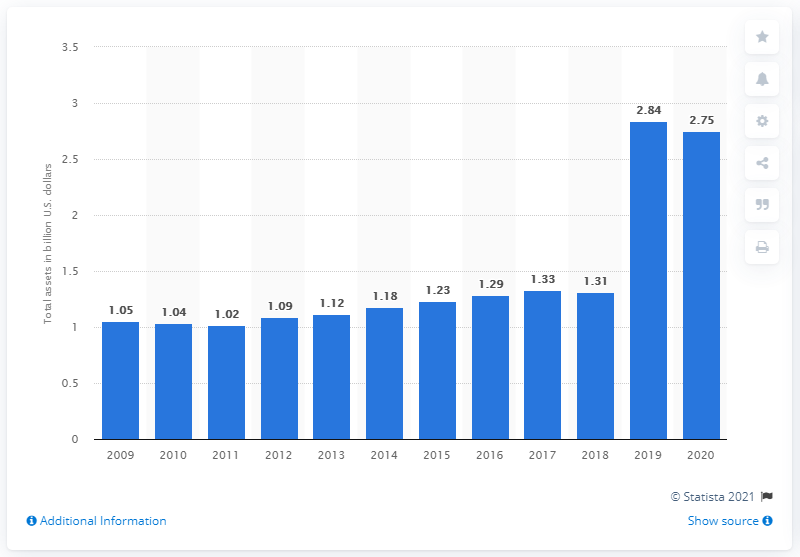Highlight a few significant elements in this photo. The total amount of The Cheesecake Factory's assets was 2.75. In the previous year, the total assets of The Cheesecake Factory were 2.84 billion dollars. 